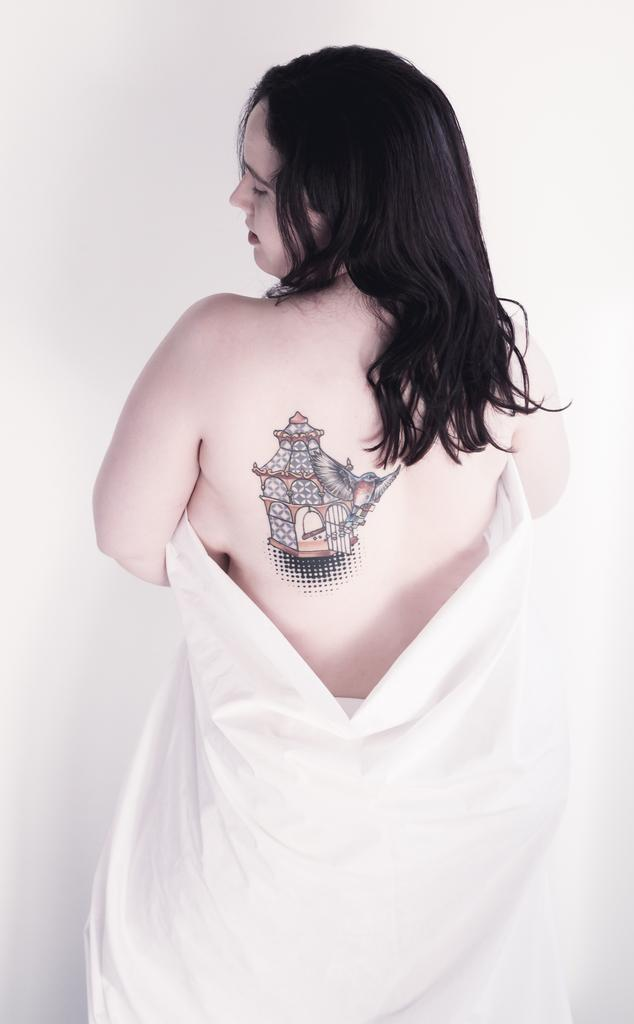Who is the main subject in the image? There is a woman in the image. Can you describe any distinguishing features of the woman? The woman has a tattoo on her back. What is the color of the background in the image? The background of the image is white. How many teeth are visible on the toothbrush in the image? There is no toothbrush present in the image, so it is not possible to determine how many teeth are visible on it. 